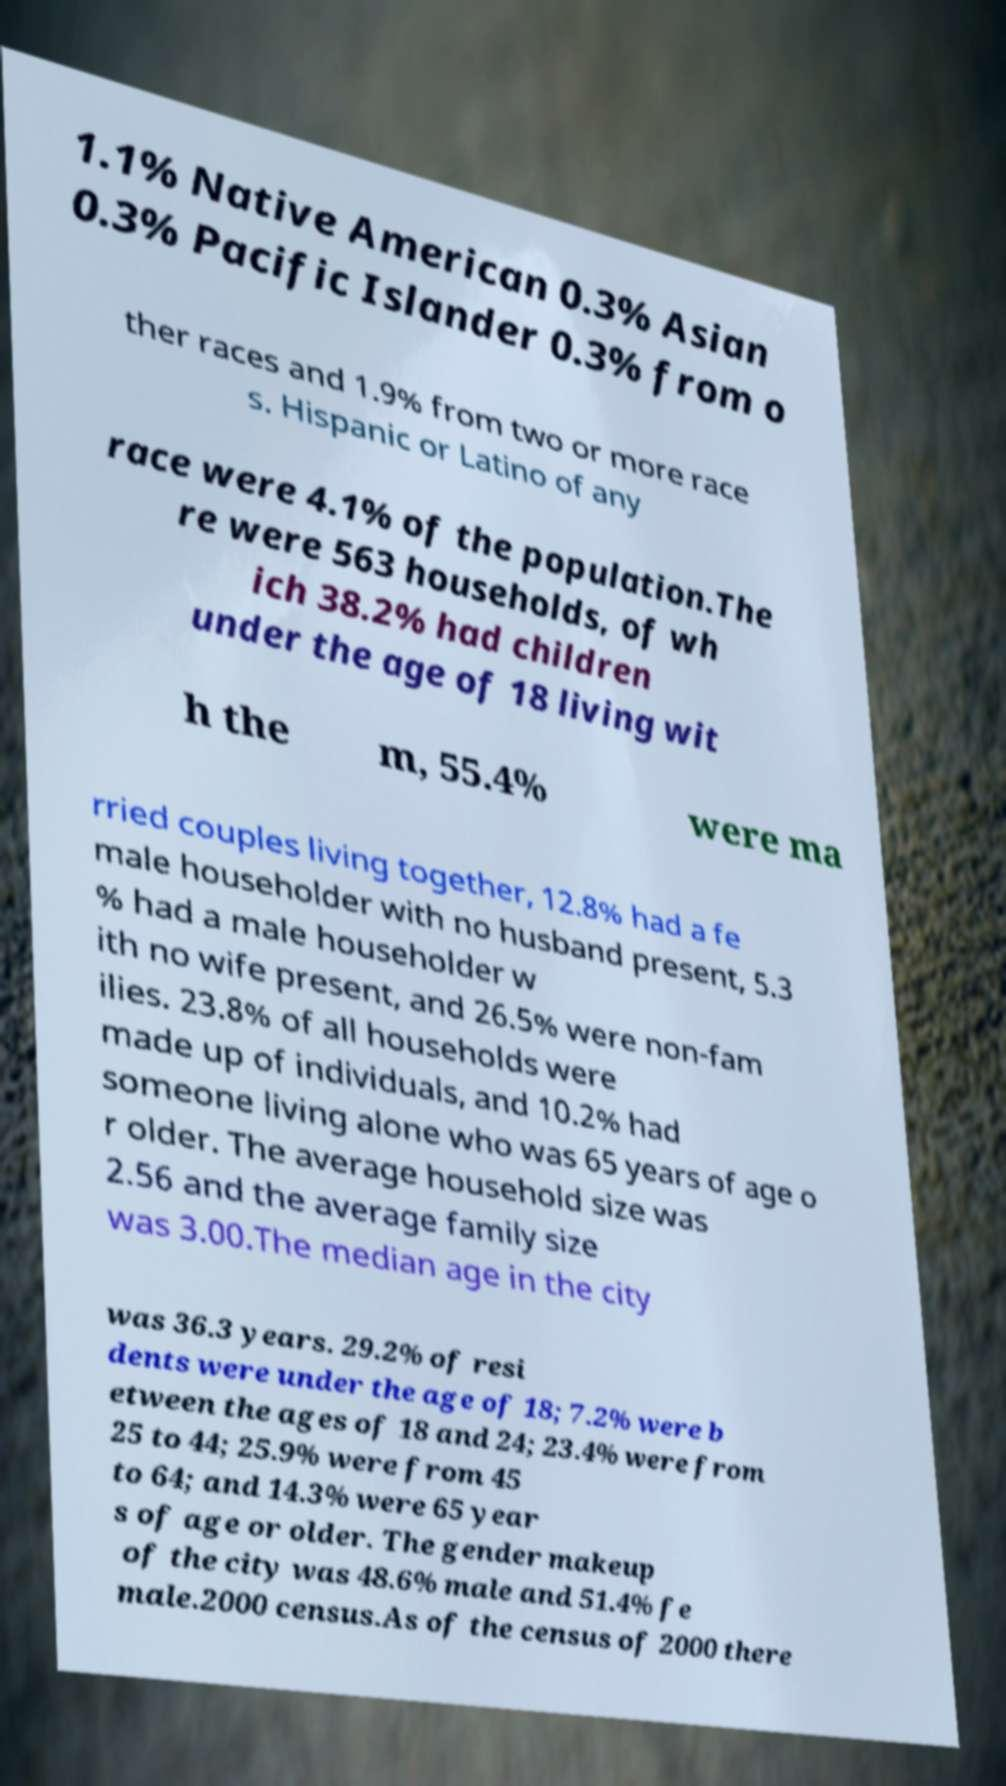For documentation purposes, I need the text within this image transcribed. Could you provide that? 1.1% Native American 0.3% Asian 0.3% Pacific Islander 0.3% from o ther races and 1.9% from two or more race s. Hispanic or Latino of any race were 4.1% of the population.The re were 563 households, of wh ich 38.2% had children under the age of 18 living wit h the m, 55.4% were ma rried couples living together, 12.8% had a fe male householder with no husband present, 5.3 % had a male householder w ith no wife present, and 26.5% were non-fam ilies. 23.8% of all households were made up of individuals, and 10.2% had someone living alone who was 65 years of age o r older. The average household size was 2.56 and the average family size was 3.00.The median age in the city was 36.3 years. 29.2% of resi dents were under the age of 18; 7.2% were b etween the ages of 18 and 24; 23.4% were from 25 to 44; 25.9% were from 45 to 64; and 14.3% were 65 year s of age or older. The gender makeup of the city was 48.6% male and 51.4% fe male.2000 census.As of the census of 2000 there 